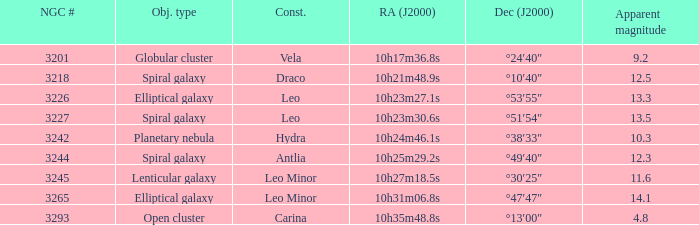What is the total of Apparent magnitudes for an NGC number larger than 3293? None. 